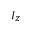<formula> <loc_0><loc_0><loc_500><loc_500>I _ { Z }</formula> 